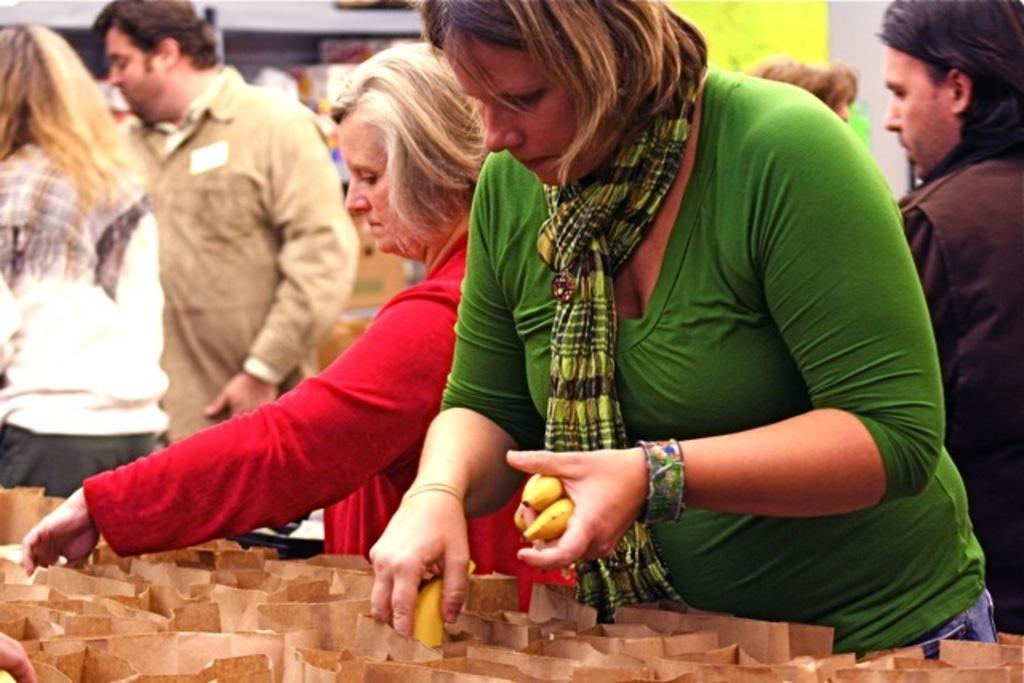Can you describe this image briefly? In this picture we can observe two women standing in front of a table on which some brown color packets are placed. We can observe bananas in one of the women's hand. She is wearing green color T shirt and a scarf around her neck. In the background there are some people standing. 